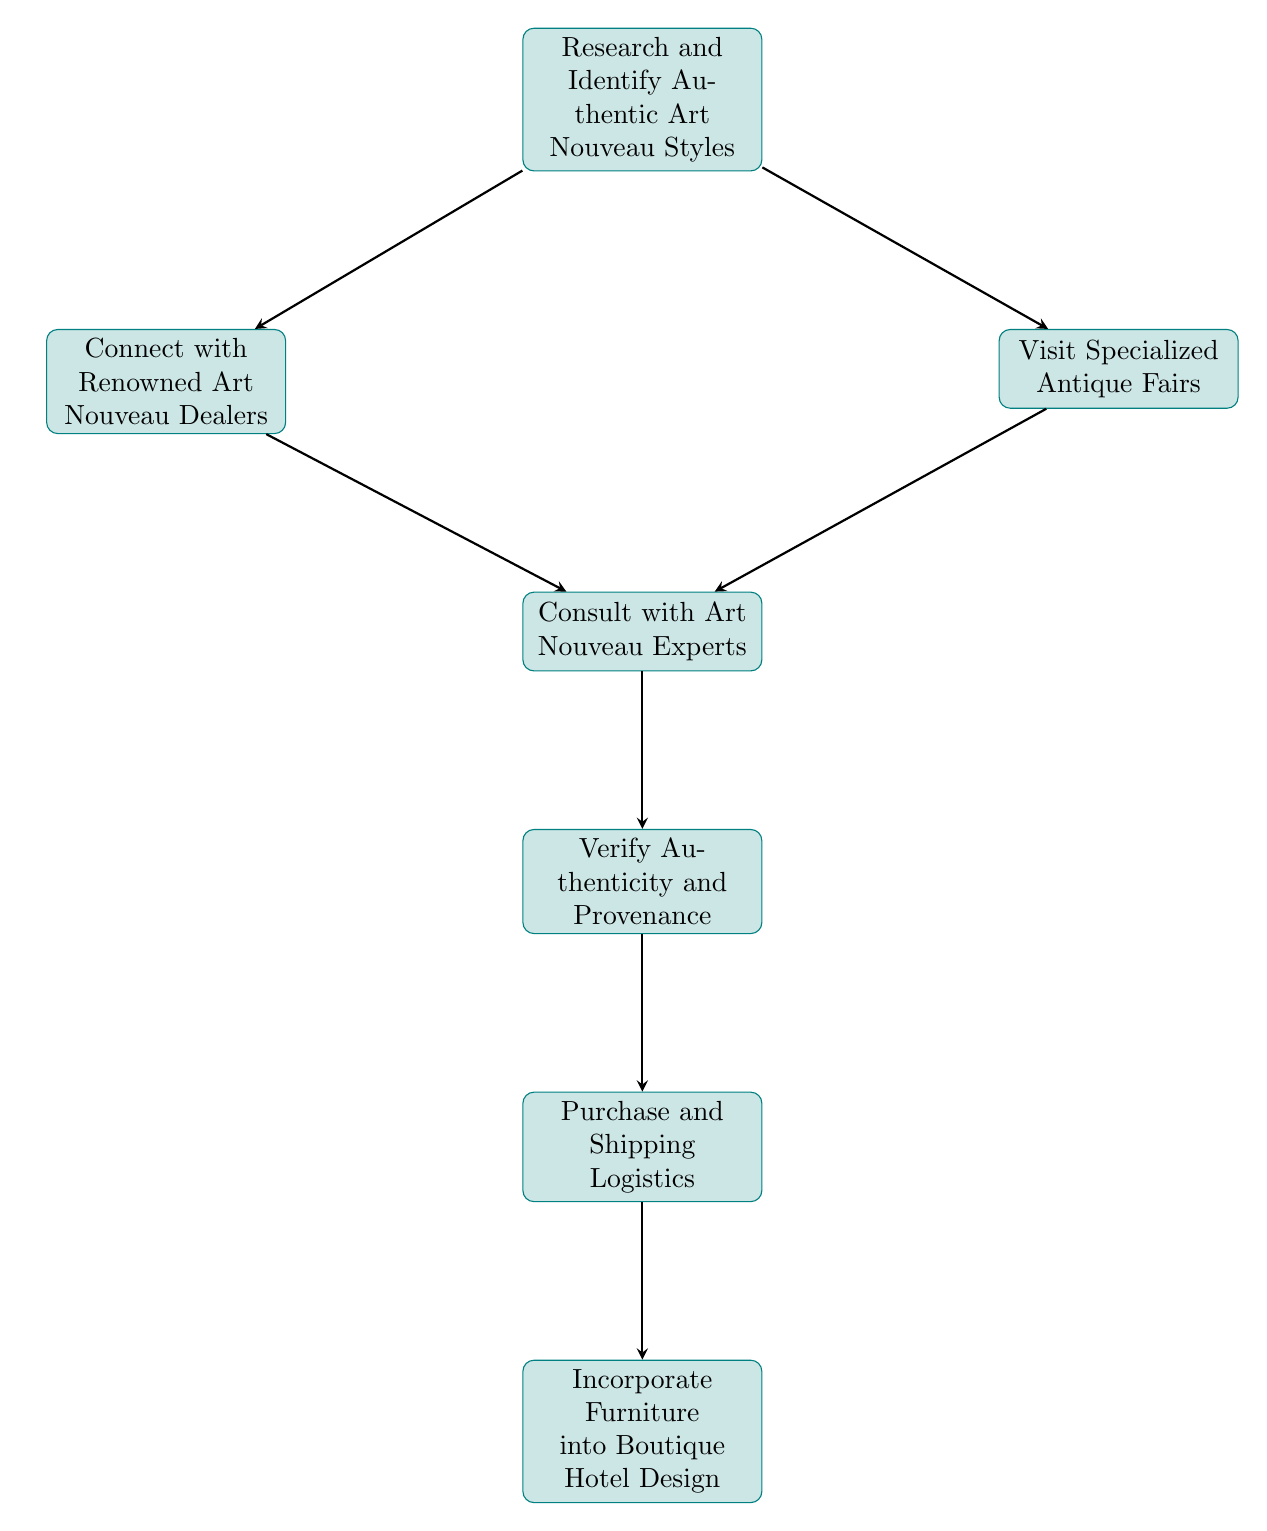What is the first step in identifying genuine Art Nouveau furniture? The diagram indicates that the first step is "Research and Identify Authentic Art Nouveau Styles," which lays the foundation for understanding the characteristics of the furniture.
Answer: Research and Identify Authentic Art Nouveau Styles How many nodes are there in the diagram? By counting the nodes listed in the data structure, we find that there are a total of seven distinct nodes representing different steps in the process.
Answer: 7 What comes after connecting with renowned art dealers? According to the connections outlined, after "Connect with Renowned Art Nouveau Dealers," the next step is to "Consult with Art Nouveau Experts."
Answer: Consult with Art Nouveau Experts What is the final stage in procuring genuine Art Nouveau furniture? The final stage, as displayed in the last node of the flow chart, is "Incorporate Furniture into Boutique Hotel Design," where the purchased pieces are integrated into the hotel setting.
Answer: Incorporate Furniture into Boutique Hotel Design If you attend specialized antique fairs, whom should you consult next? Following the connection from "Visit Specialized Antique Fairs," the logical next step is to "Consult with Art Nouveau Experts," as both paths converge at this node.
Answer: Consult with Art Nouveau Experts What verification step must be taken before logistics? The verification step that must occur before moving to logistics is "Verify Authenticity and Provenance," ensuring that all pieces are authentic and traceable.
Answer: Verify Authenticity and Provenance Which node has the most incoming connections? The complexity and interconnectedness of the diagram show that "Consult with Art Nouveau Experts" receives connections from both "Connect with Renowned Art Nouveau Dealers" and "Visit Specialized Antique Fairs," making it the node with the most incoming connections.
Answer: Consult with Art Nouveau Experts 